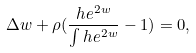Convert formula to latex. <formula><loc_0><loc_0><loc_500><loc_500>\Delta w + \rho ( \frac { h e ^ { 2 w } } { \int h e ^ { 2 w } } - 1 ) = 0 ,</formula> 